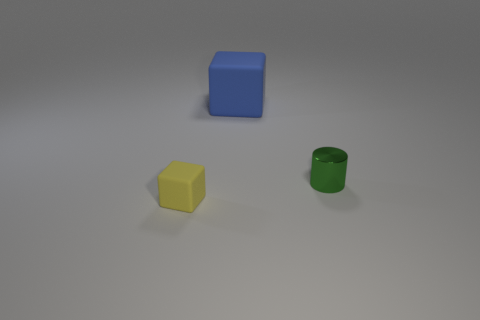Subtract 2 blocks. How many blocks are left? 0 Subtract all cylinders. How many objects are left? 2 Subtract all purple balls. How many yellow cubes are left? 1 Add 3 small yellow rubber cubes. How many small yellow rubber cubes are left? 4 Add 1 large purple matte cubes. How many large purple matte cubes exist? 1 Add 1 yellow things. How many objects exist? 4 Subtract 1 green cylinders. How many objects are left? 2 Subtract all cyan cylinders. Subtract all blue cubes. How many cylinders are left? 1 Subtract all yellow blocks. Subtract all small cubes. How many objects are left? 1 